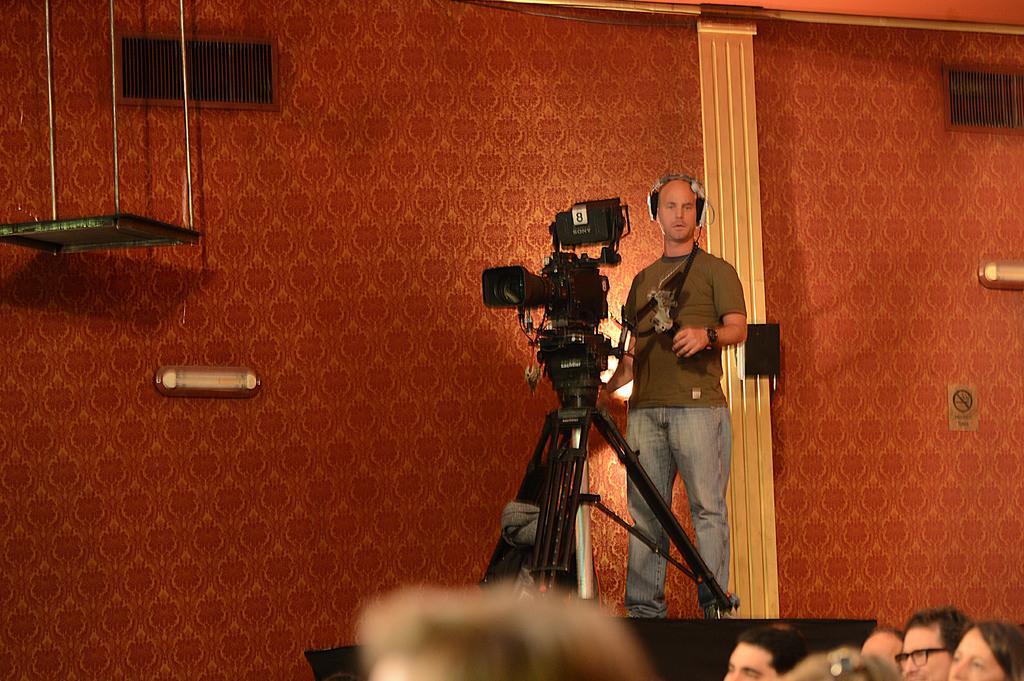Describe this image in one or two sentences. In this picture I can see a person is standing and wearing headphones. Here I can see a video camera. Here I can see group of people and a wall which has some objects attached to it. Here I can see an object. 